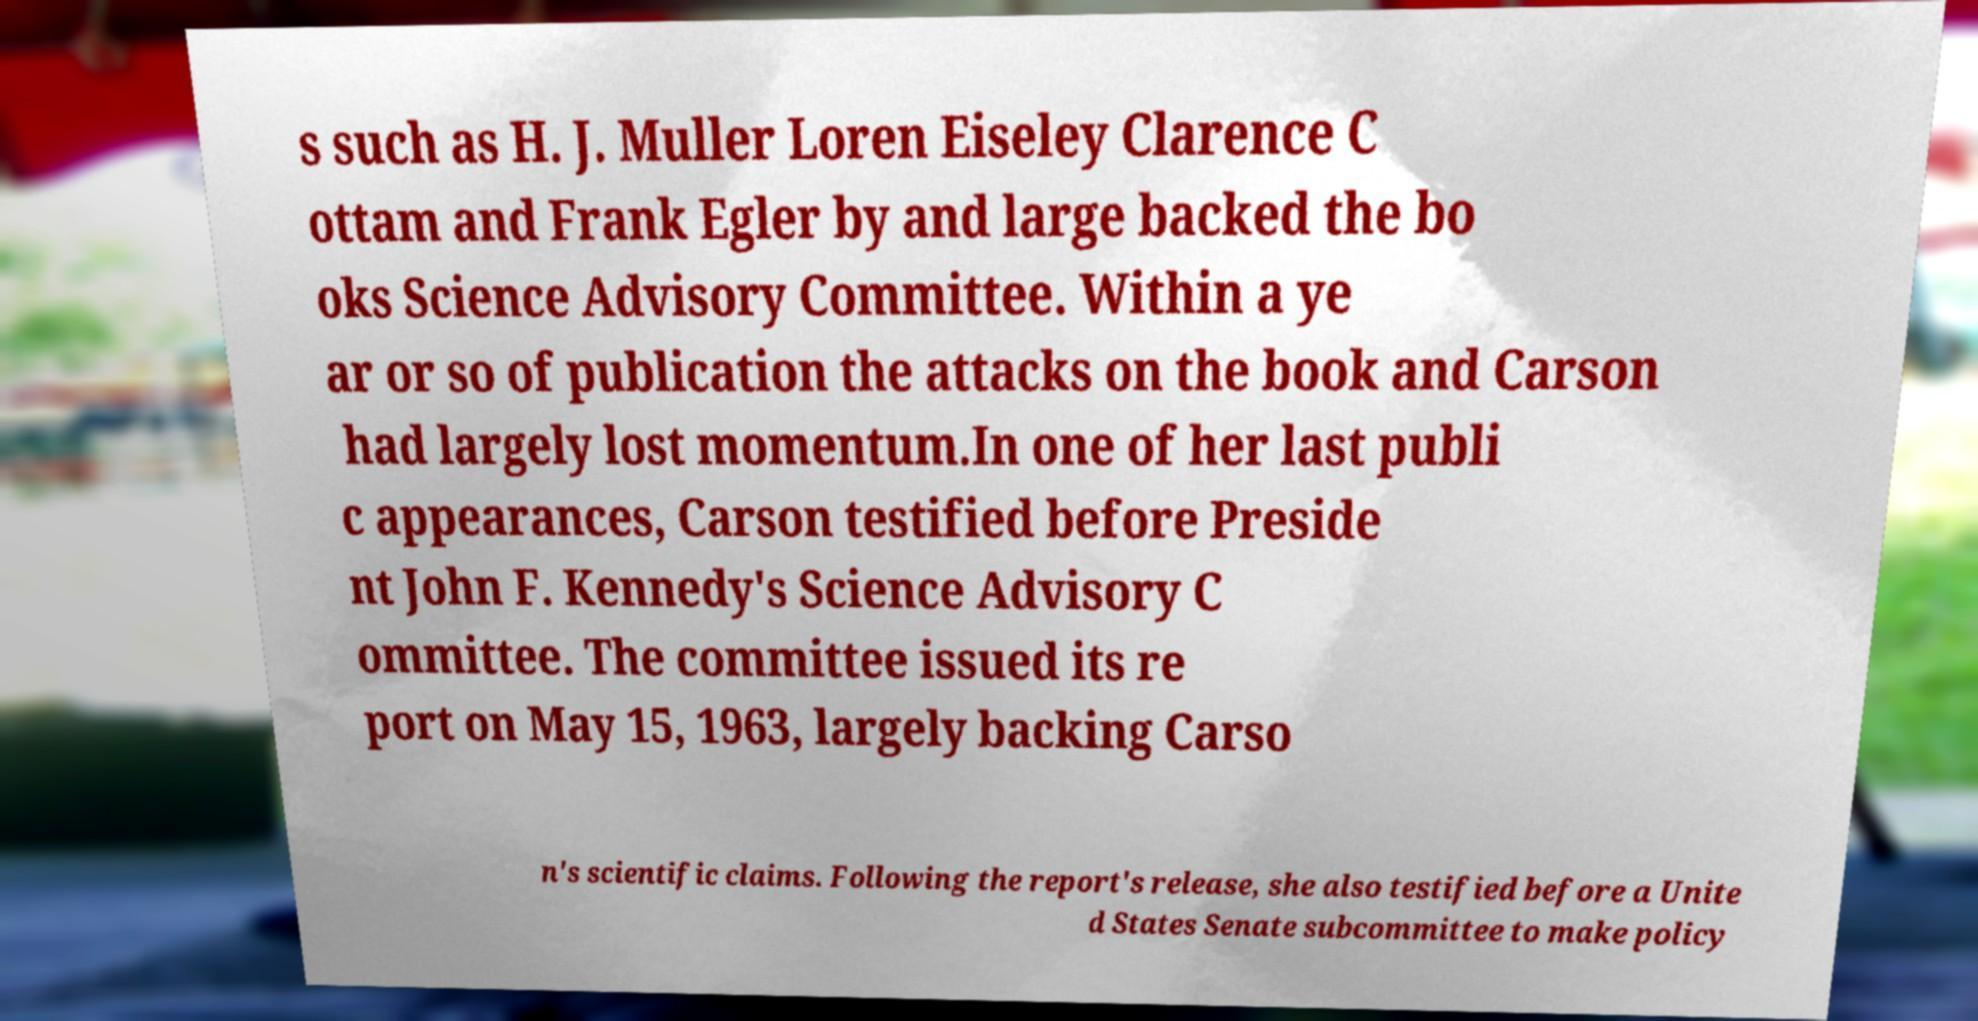Please read and relay the text visible in this image. What does it say? s such as H. J. Muller Loren Eiseley Clarence C ottam and Frank Egler by and large backed the bo oks Science Advisory Committee. Within a ye ar or so of publication the attacks on the book and Carson had largely lost momentum.In one of her last publi c appearances, Carson testified before Preside nt John F. Kennedy's Science Advisory C ommittee. The committee issued its re port on May 15, 1963, largely backing Carso n's scientific claims. Following the report's release, she also testified before a Unite d States Senate subcommittee to make policy 